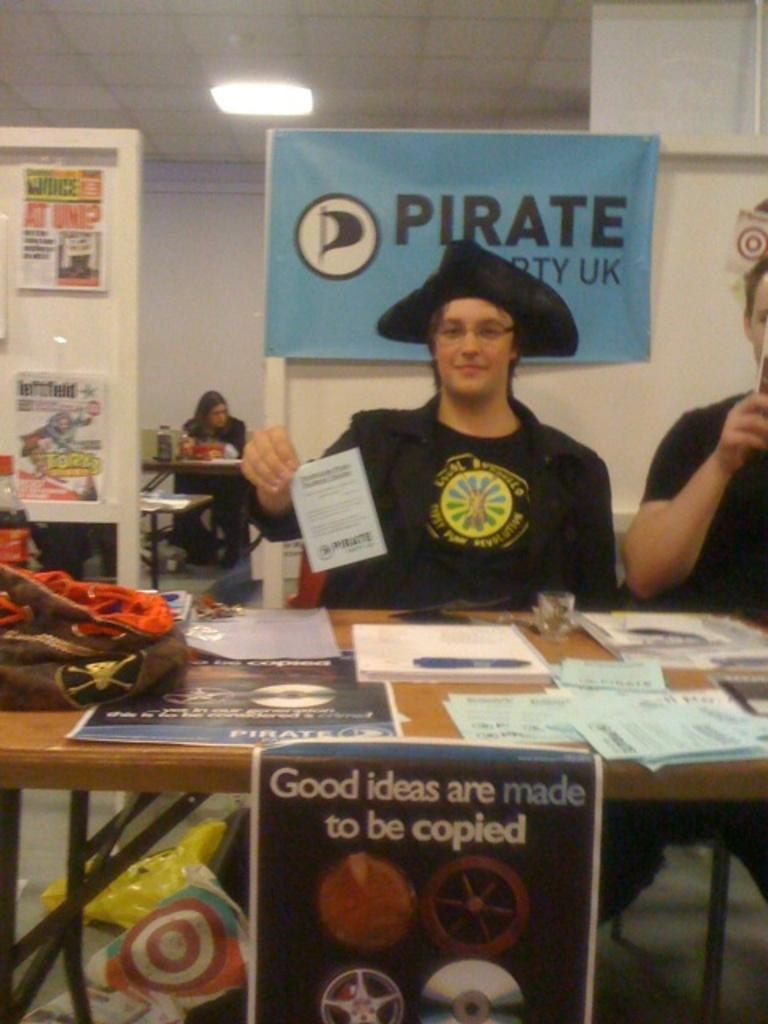<image>
Give a short and clear explanation of the subsequent image. A woman in a bllack hat sits in front of a blue sign that says pirate. 